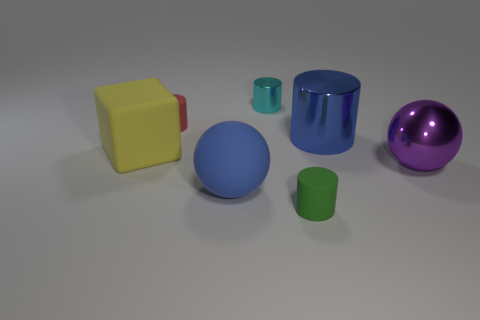Add 1 small green rubber cylinders. How many objects exist? 8 Subtract all small green rubber cylinders. How many cylinders are left? 3 Subtract all blocks. How many objects are left? 6 Subtract 2 cylinders. How many cylinders are left? 2 Subtract all green cylinders. How many cylinders are left? 3 Subtract all brown cubes. Subtract all gray cylinders. How many cubes are left? 1 Subtract all yellow cylinders. How many red spheres are left? 0 Subtract all big purple metal balls. Subtract all large metallic cylinders. How many objects are left? 5 Add 3 large rubber spheres. How many large rubber spheres are left? 4 Add 6 metal cylinders. How many metal cylinders exist? 8 